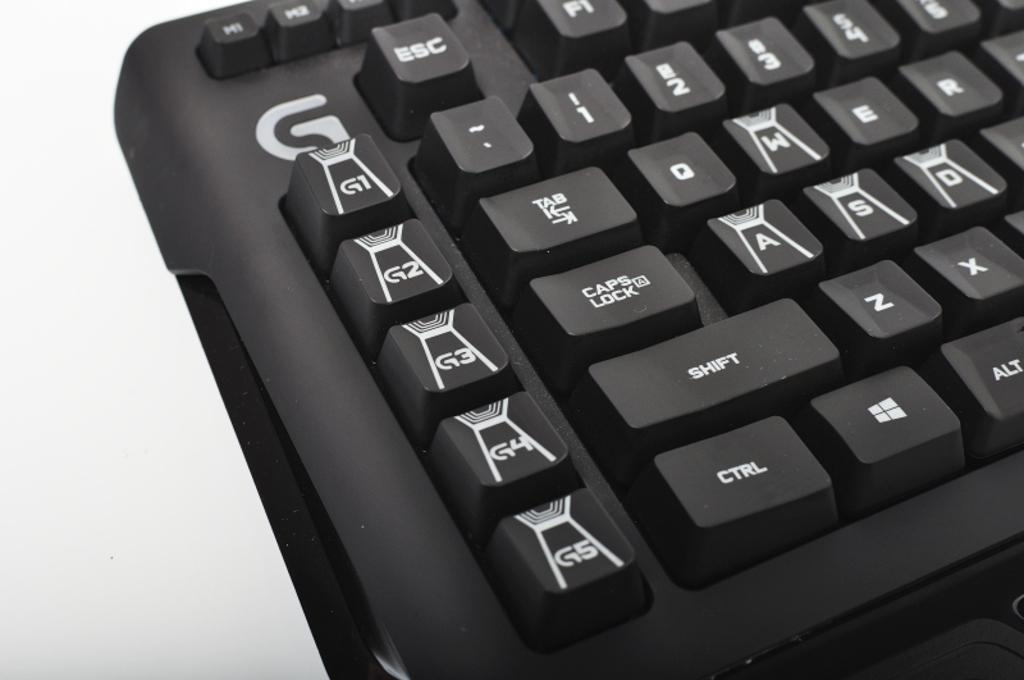<image>
Give a short and clear explanation of the subsequent image. a close up of a black keyboard has keys on the left for G5, G4 